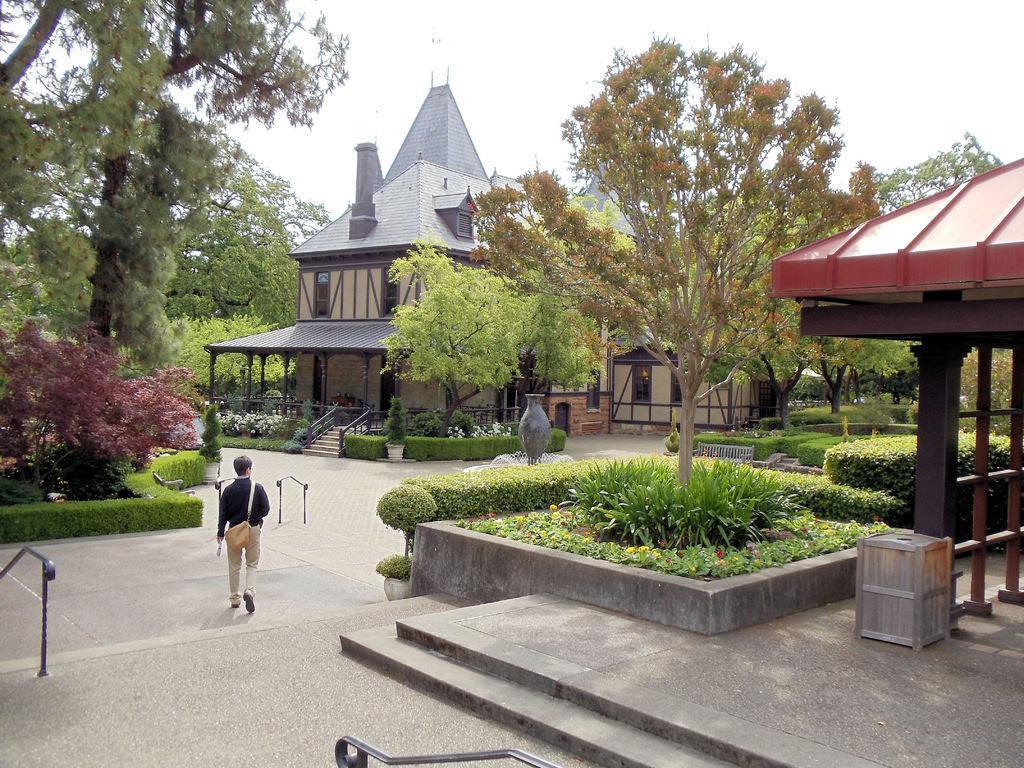Please provide a concise description of this image. In this image we can see a person on the floor, there are metal railings, a wooden box near the shed and there are few plants, trees, a bench, fountain, a building, stairs in front of the building and the sky in the background. 